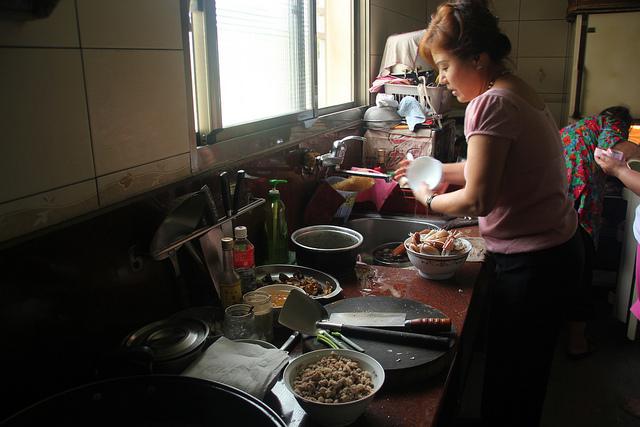Is there someone else in the kitchen?
Write a very short answer. Yes. What is the woman in the pink shirt doing?
Short answer required. Cooking. What is the utensil with the brown wooden handle?
Answer briefly. Knife. 